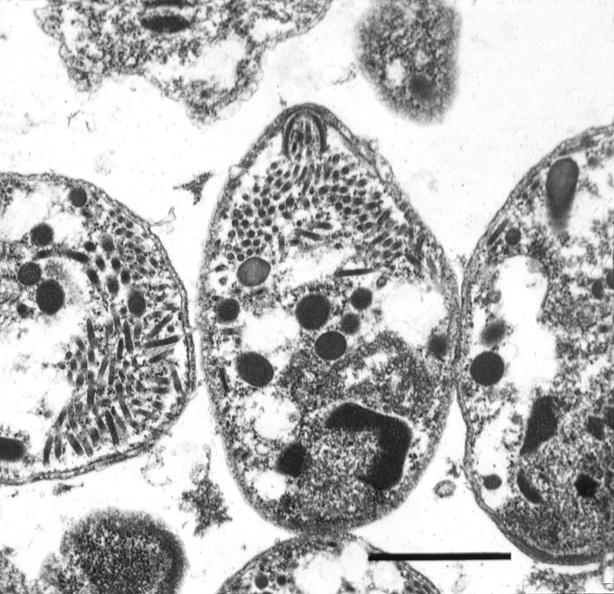does epididymis show brain, toxoplasma encephalitis?
Answer the question using a single word or phrase. No 